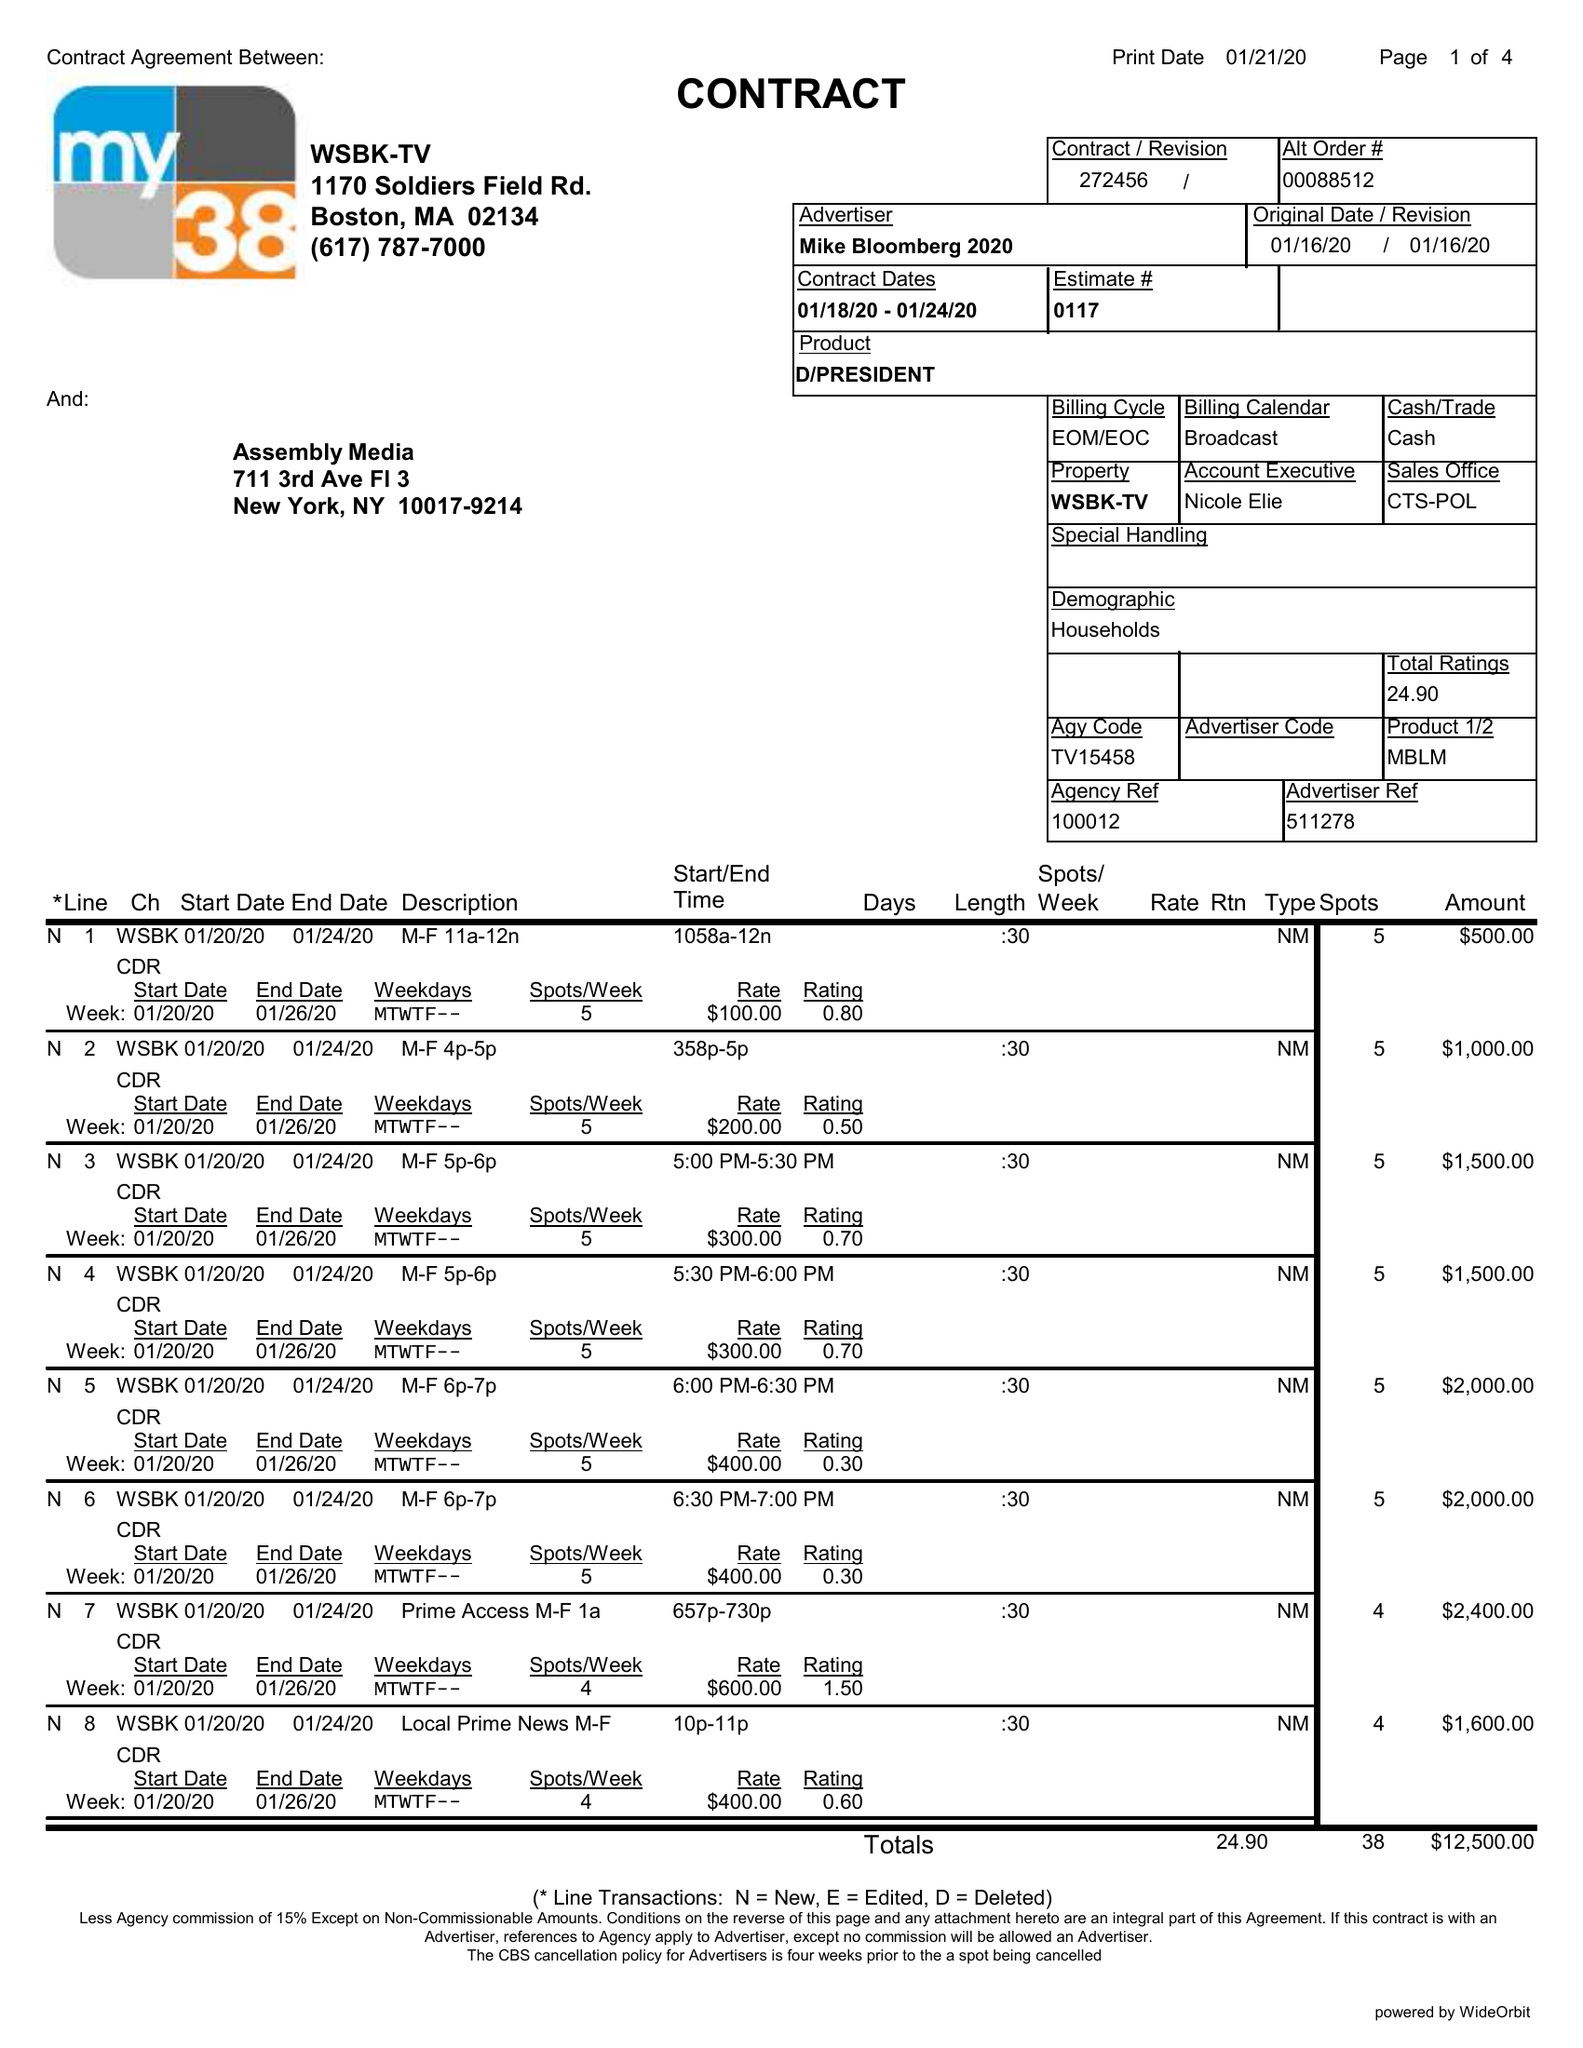What is the value for the flight_from?
Answer the question using a single word or phrase. 01/18/20 